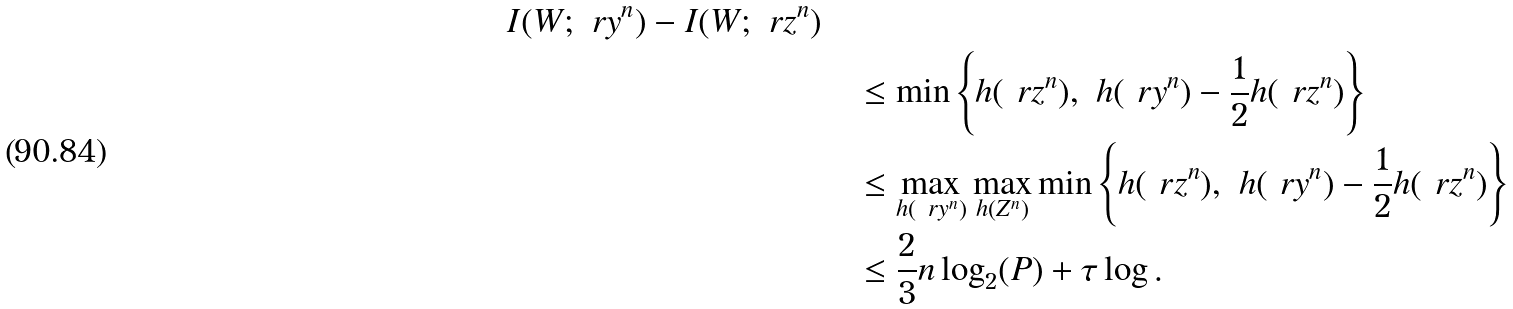Convert formula to latex. <formula><loc_0><loc_0><loc_500><loc_500>{ I ( W ; \ r y ^ { n } ) - I ( W ; \ r z ^ { n } ) } \quad \\ & \leq \min \left \{ h ( \ r z ^ { n } ) , \ h ( \ r y ^ { n } ) - \frac { 1 } { 2 } h ( \ r z ^ { n } ) \right \} \\ & \leq \max _ { h ( \ r y ^ { n } ) } \max _ { h ( Z ^ { n } ) } \min \left \{ h ( \ r z ^ { n } ) , \ h ( \ r y ^ { n } ) - \frac { 1 } { 2 } h ( \ r z ^ { n } ) \right \} \\ & \leq \frac { 2 } { 3 } n \log _ { 2 } ( P ) + \tau \log .</formula> 